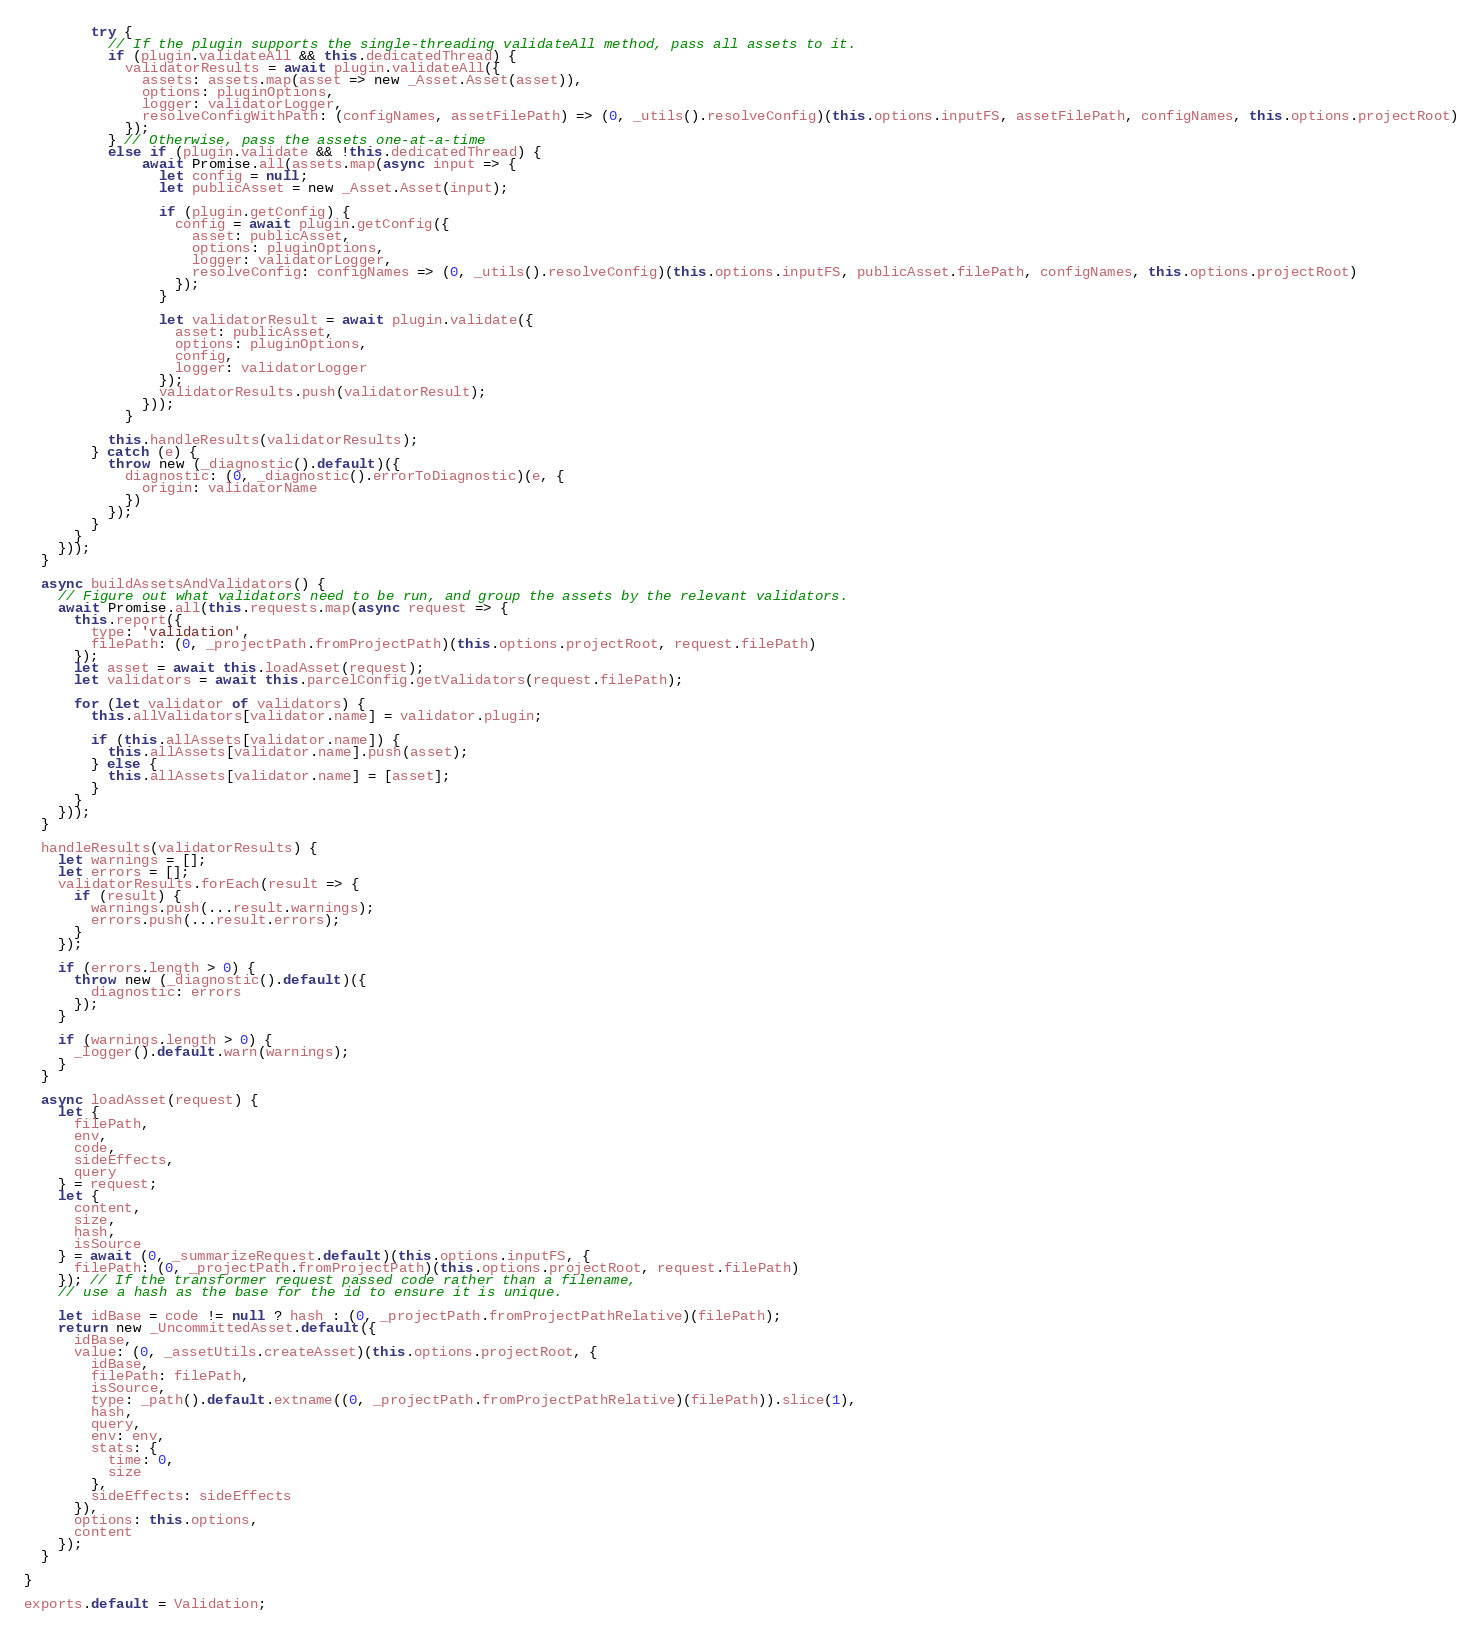<code> <loc_0><loc_0><loc_500><loc_500><_JavaScript_>        try {
          // If the plugin supports the single-threading validateAll method, pass all assets to it.
          if (plugin.validateAll && this.dedicatedThread) {
            validatorResults = await plugin.validateAll({
              assets: assets.map(asset => new _Asset.Asset(asset)),
              options: pluginOptions,
              logger: validatorLogger,
              resolveConfigWithPath: (configNames, assetFilePath) => (0, _utils().resolveConfig)(this.options.inputFS, assetFilePath, configNames, this.options.projectRoot)
            });
          } // Otherwise, pass the assets one-at-a-time
          else if (plugin.validate && !this.dedicatedThread) {
              await Promise.all(assets.map(async input => {
                let config = null;
                let publicAsset = new _Asset.Asset(input);

                if (plugin.getConfig) {
                  config = await plugin.getConfig({
                    asset: publicAsset,
                    options: pluginOptions,
                    logger: validatorLogger,
                    resolveConfig: configNames => (0, _utils().resolveConfig)(this.options.inputFS, publicAsset.filePath, configNames, this.options.projectRoot)
                  });
                }

                let validatorResult = await plugin.validate({
                  asset: publicAsset,
                  options: pluginOptions,
                  config,
                  logger: validatorLogger
                });
                validatorResults.push(validatorResult);
              }));
            }

          this.handleResults(validatorResults);
        } catch (e) {
          throw new (_diagnostic().default)({
            diagnostic: (0, _diagnostic().errorToDiagnostic)(e, {
              origin: validatorName
            })
          });
        }
      }
    }));
  }

  async buildAssetsAndValidators() {
    // Figure out what validators need to be run, and group the assets by the relevant validators.
    await Promise.all(this.requests.map(async request => {
      this.report({
        type: 'validation',
        filePath: (0, _projectPath.fromProjectPath)(this.options.projectRoot, request.filePath)
      });
      let asset = await this.loadAsset(request);
      let validators = await this.parcelConfig.getValidators(request.filePath);

      for (let validator of validators) {
        this.allValidators[validator.name] = validator.plugin;

        if (this.allAssets[validator.name]) {
          this.allAssets[validator.name].push(asset);
        } else {
          this.allAssets[validator.name] = [asset];
        }
      }
    }));
  }

  handleResults(validatorResults) {
    let warnings = [];
    let errors = [];
    validatorResults.forEach(result => {
      if (result) {
        warnings.push(...result.warnings);
        errors.push(...result.errors);
      }
    });

    if (errors.length > 0) {
      throw new (_diagnostic().default)({
        diagnostic: errors
      });
    }

    if (warnings.length > 0) {
      _logger().default.warn(warnings);
    }
  }

  async loadAsset(request) {
    let {
      filePath,
      env,
      code,
      sideEffects,
      query
    } = request;
    let {
      content,
      size,
      hash,
      isSource
    } = await (0, _summarizeRequest.default)(this.options.inputFS, {
      filePath: (0, _projectPath.fromProjectPath)(this.options.projectRoot, request.filePath)
    }); // If the transformer request passed code rather than a filename,
    // use a hash as the base for the id to ensure it is unique.

    let idBase = code != null ? hash : (0, _projectPath.fromProjectPathRelative)(filePath);
    return new _UncommittedAsset.default({
      idBase,
      value: (0, _assetUtils.createAsset)(this.options.projectRoot, {
        idBase,
        filePath: filePath,
        isSource,
        type: _path().default.extname((0, _projectPath.fromProjectPathRelative)(filePath)).slice(1),
        hash,
        query,
        env: env,
        stats: {
          time: 0,
          size
        },
        sideEffects: sideEffects
      }),
      options: this.options,
      content
    });
  }

}

exports.default = Validation;</code> 